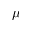<formula> <loc_0><loc_0><loc_500><loc_500>\mu</formula> 